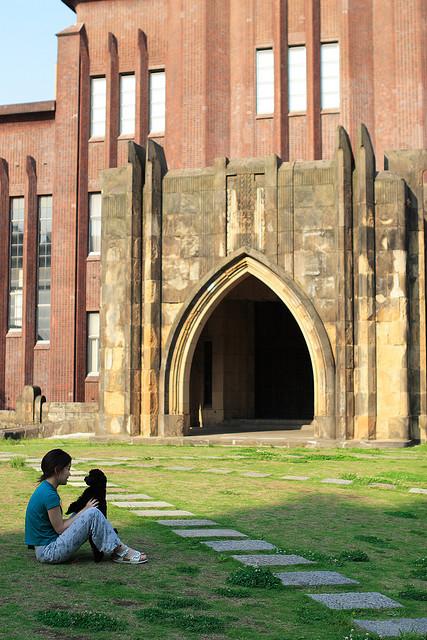What is the opening to this building called?
Be succinct. Arch. What type of animal does the person hold?
Give a very brief answer. Dog. IS this person male or female?
Write a very short answer. Female. 